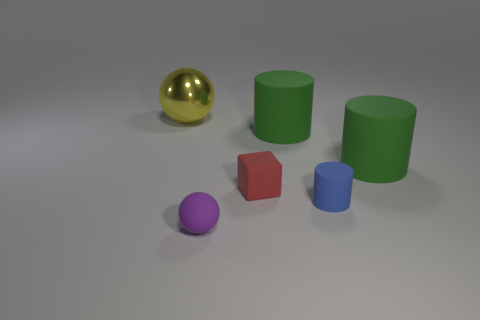Subtract all green cylinders. How many were subtracted if there are1green cylinders left? 1 Subtract 1 cylinders. How many cylinders are left? 2 Subtract all green spheres. How many green cylinders are left? 2 Subtract all large cylinders. How many cylinders are left? 1 Add 1 tiny blue rubber cylinders. How many objects exist? 7 Subtract all blocks. How many objects are left? 5 Subtract all brown cylinders. Subtract all brown spheres. How many cylinders are left? 3 Add 6 yellow metal spheres. How many yellow metal spheres are left? 7 Add 6 small purple things. How many small purple things exist? 7 Subtract 0 purple cylinders. How many objects are left? 6 